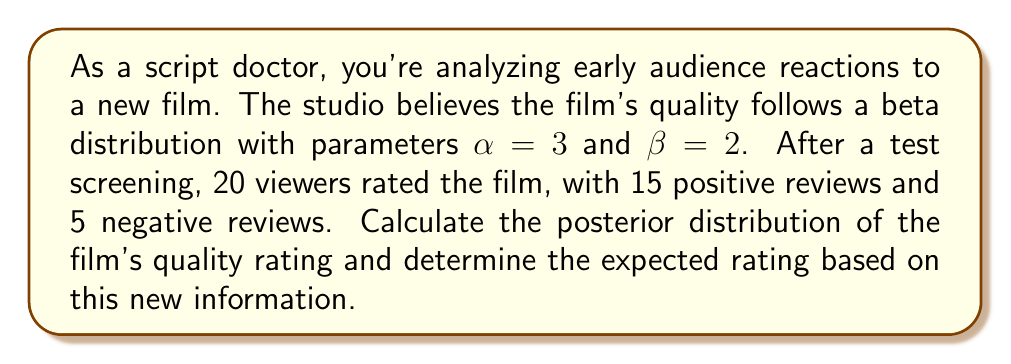What is the answer to this math problem? Let's approach this step-by-step using Bayesian inference:

1) The prior distribution is Beta($\alpha=3$, $\beta=2$).

2) We're dealing with a binomial likelihood (positive/negative reviews) and a beta prior, which form a conjugate pair. This means our posterior will also be a beta distribution.

3) For a beta-binomial model, the posterior parameters are calculated as:
   $\alpha_{posterior} = \alpha_{prior} + \text{number of successes}$
   $\beta_{posterior} = \beta_{prior} + \text{number of failures}$

4) In this case:
   $\alpha_{posterior} = 3 + 15 = 18$
   $\beta_{posterior} = 2 + 5 = 7$

5) Therefore, the posterior distribution is Beta(18, 7).

6) To find the expected rating, we use the mean of a beta distribution:
   $E[X] = \frac{\alpha}{\alpha + \beta}$

7) Plugging in our posterior parameters:
   $E[X] = \frac{18}{18 + 7} = \frac{18}{25} = 0.72$

This means that based on the prior belief and the new data from the test screening, we expect the film's quality rating to be 0.72 or 72%.
Answer: The posterior distribution is Beta(18, 7), and the expected rating is 0.72 or 72%. 